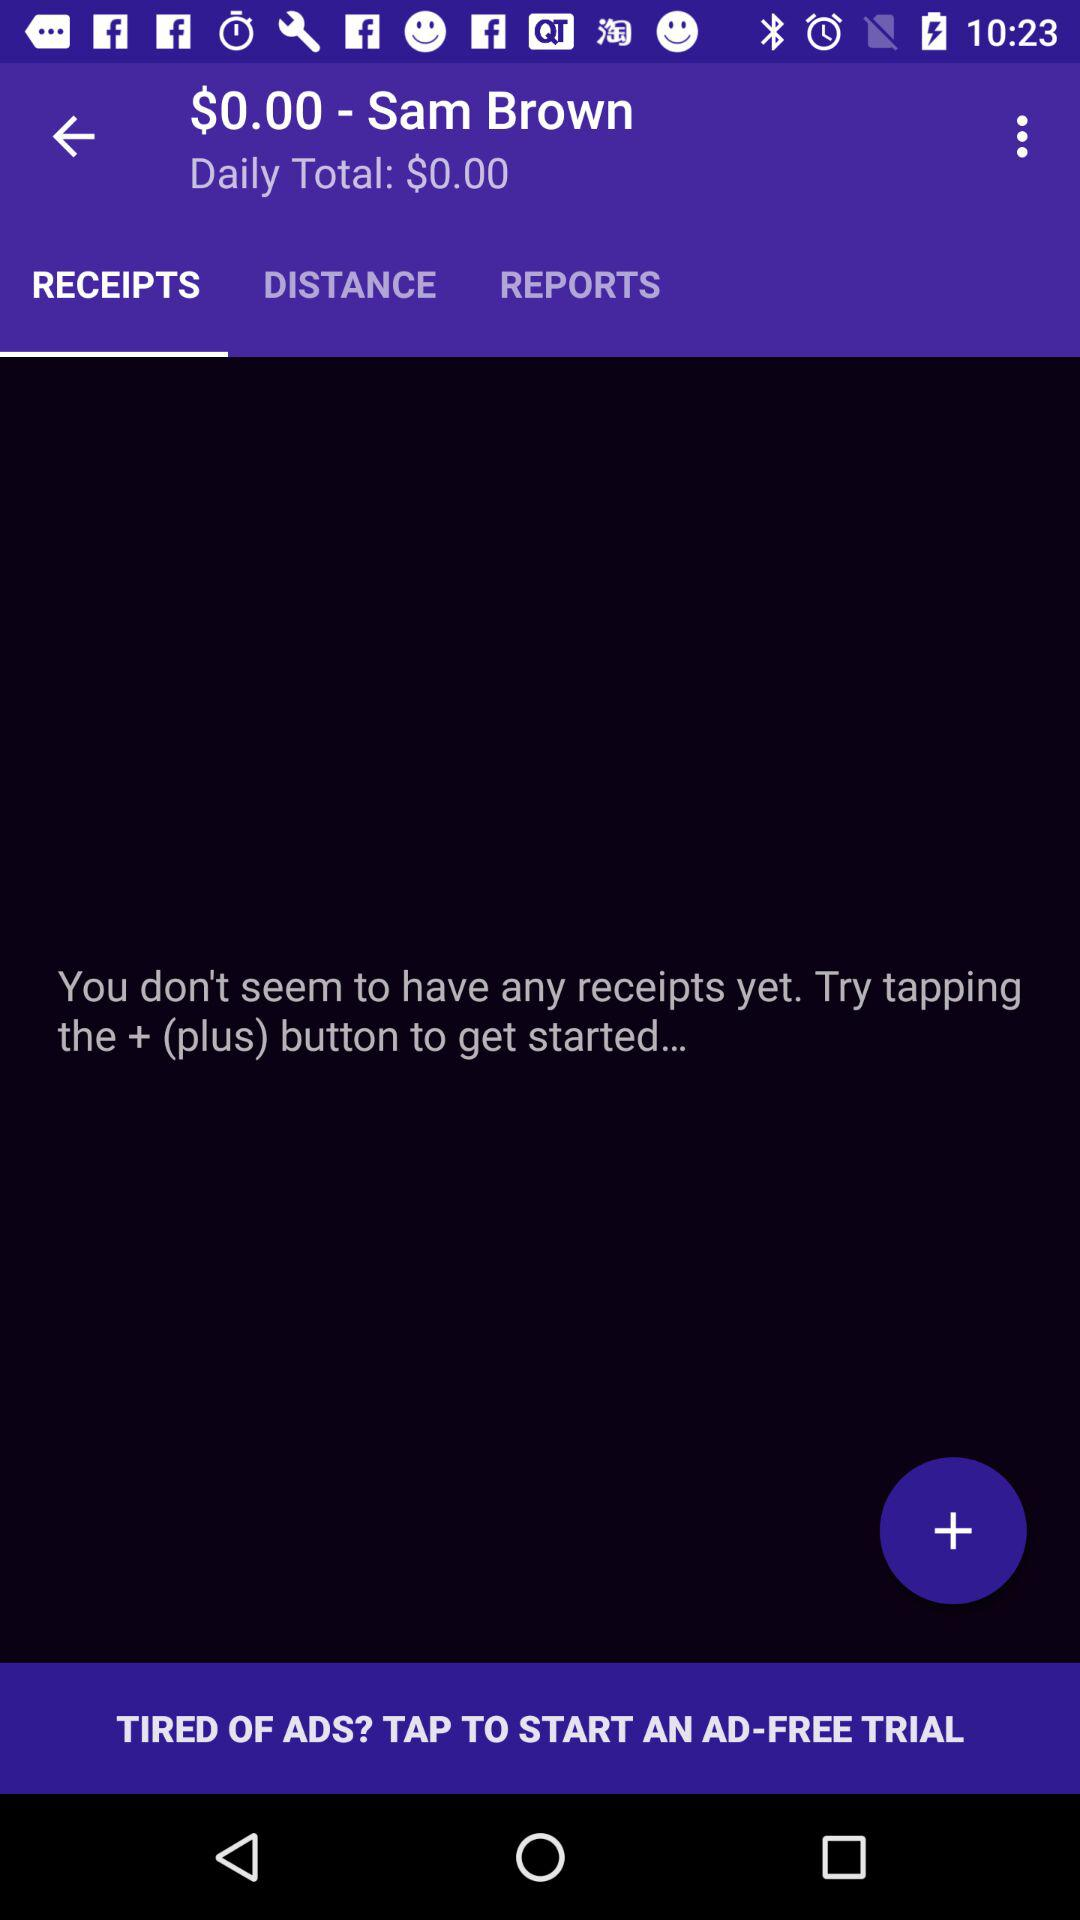What is the selected tab? The selected tab is Receipts. 